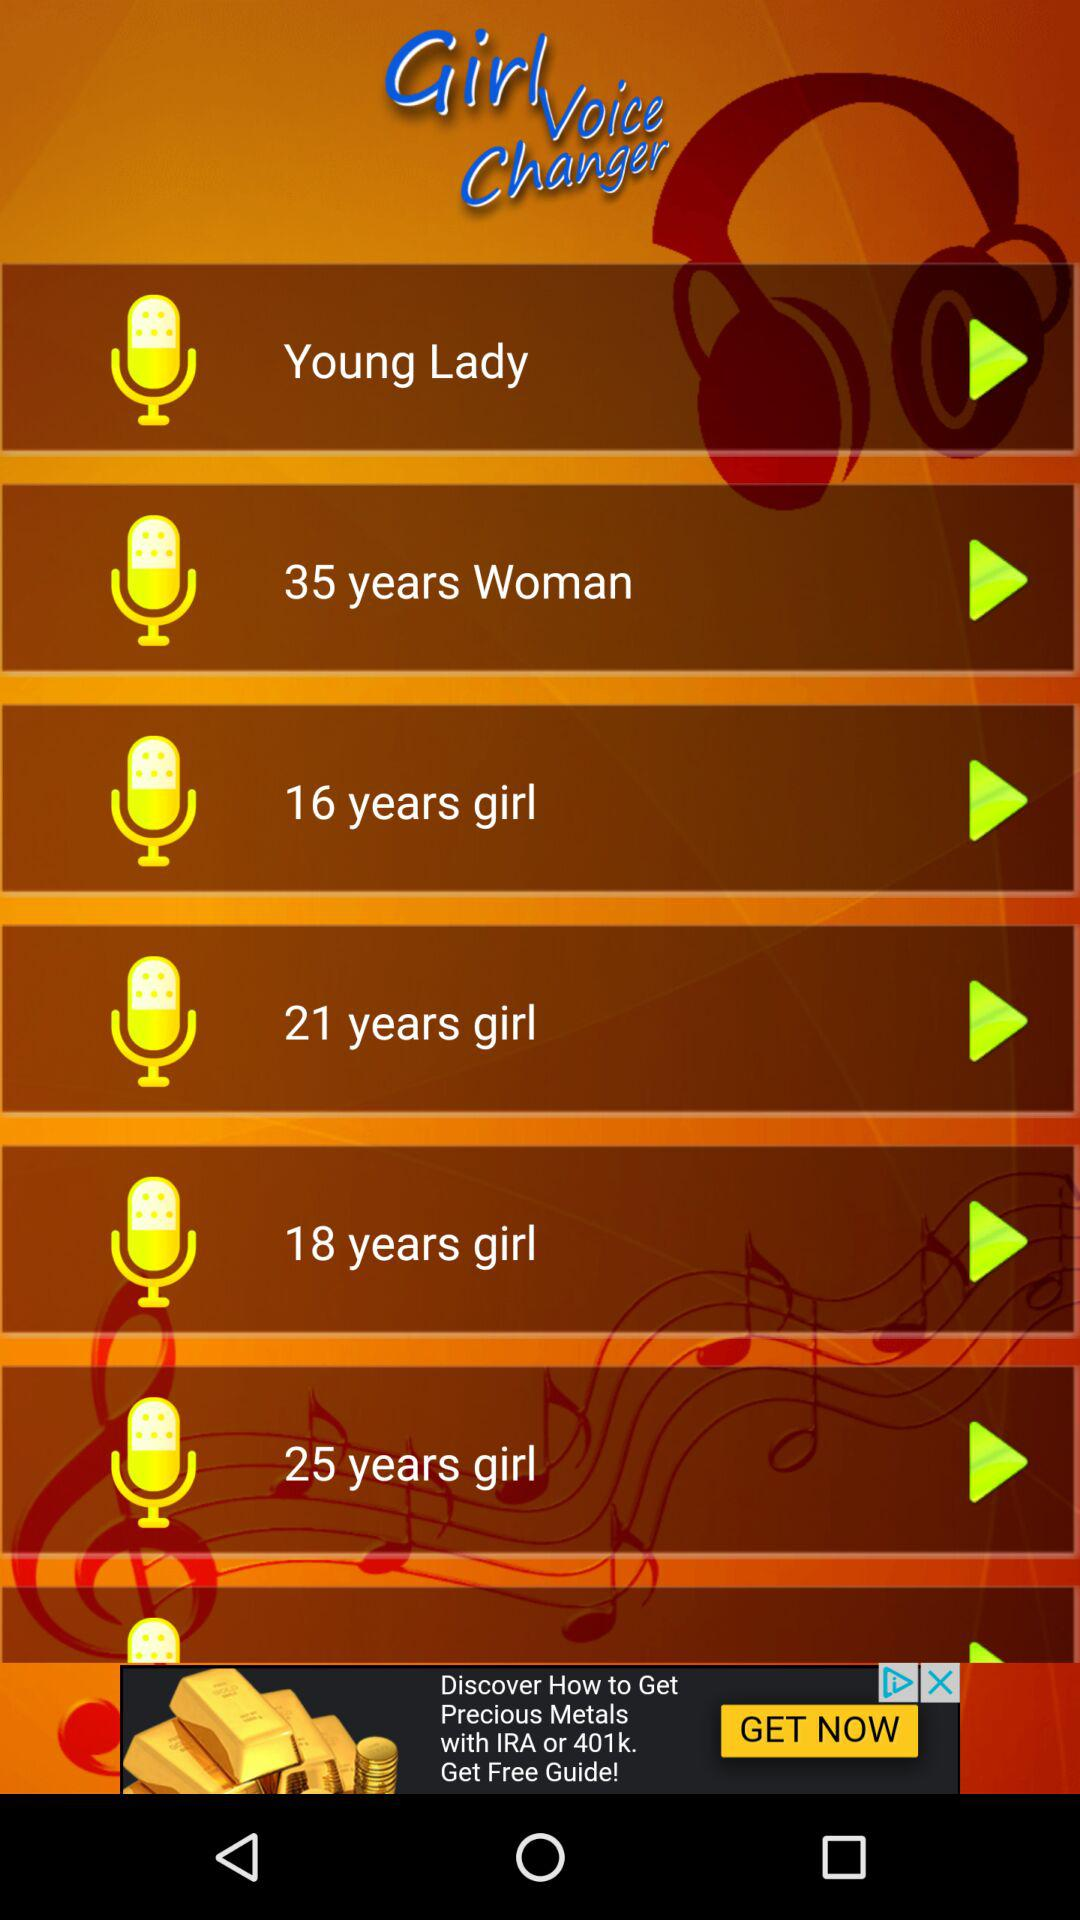What is the application name? The application name is "Girl Voice Changer". 